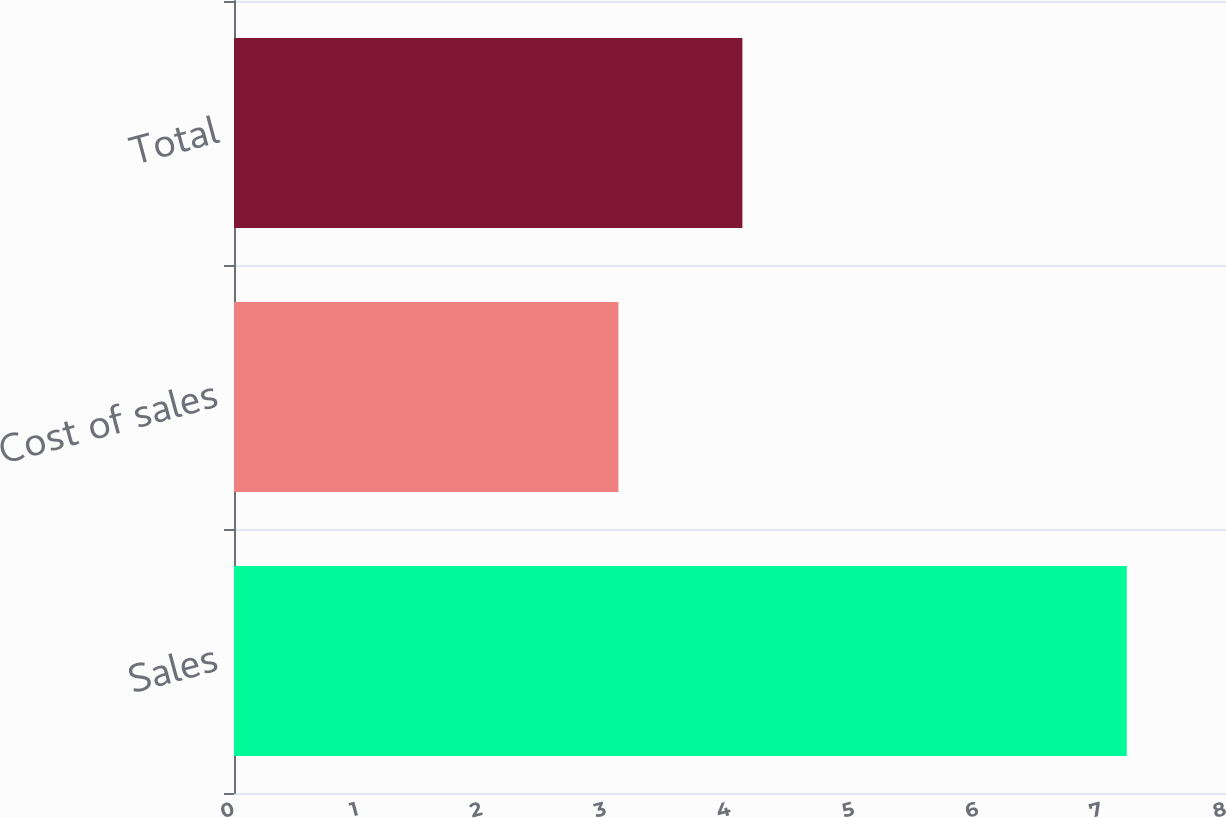Convert chart. <chart><loc_0><loc_0><loc_500><loc_500><bar_chart><fcel>Sales<fcel>Cost of sales<fcel>Total<nl><fcel>7.2<fcel>3.1<fcel>4.1<nl></chart> 